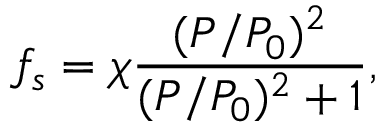<formula> <loc_0><loc_0><loc_500><loc_500>f _ { s } = \chi \frac { ( P / P _ { 0 } ) ^ { 2 } } { ( P / P _ { 0 } ) ^ { 2 } + 1 } ,</formula> 